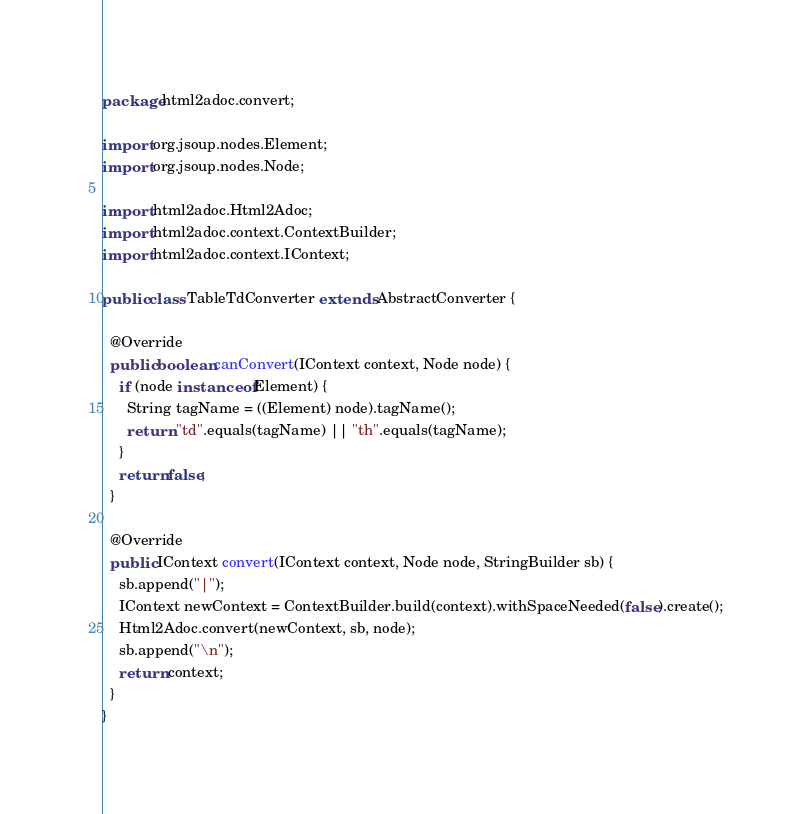<code> <loc_0><loc_0><loc_500><loc_500><_Java_>package html2adoc.convert;

import org.jsoup.nodes.Element;
import org.jsoup.nodes.Node;

import html2adoc.Html2Adoc;
import html2adoc.context.ContextBuilder;
import html2adoc.context.IContext;

public class TableTdConverter extends AbstractConverter {

  @Override
  public boolean canConvert(IContext context, Node node) {
    if (node instanceof Element) {
      String tagName = ((Element) node).tagName();
      return "td".equals(tagName) || "th".equals(tagName);
    }
    return false;
  }

  @Override
  public IContext convert(IContext context, Node node, StringBuilder sb) {
    sb.append("|");
    IContext newContext = ContextBuilder.build(context).withSpaceNeeded(false).create();
    Html2Adoc.convert(newContext, sb, node);
    sb.append("\n");
    return context;
  }
}
</code> 